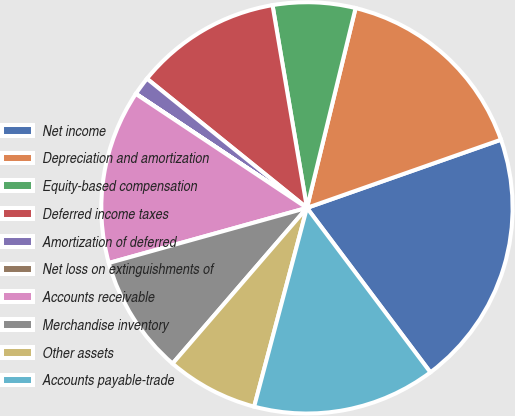Convert chart. <chart><loc_0><loc_0><loc_500><loc_500><pie_chart><fcel>Net income<fcel>Depreciation and amortization<fcel>Equity-based compensation<fcel>Deferred income taxes<fcel>Amortization of deferred<fcel>Net loss on extinguishments of<fcel>Accounts receivable<fcel>Merchandise inventory<fcel>Other assets<fcel>Accounts payable-trade<nl><fcel>20.13%<fcel>15.82%<fcel>6.48%<fcel>11.51%<fcel>1.45%<fcel>0.01%<fcel>13.67%<fcel>9.35%<fcel>7.2%<fcel>14.38%<nl></chart> 